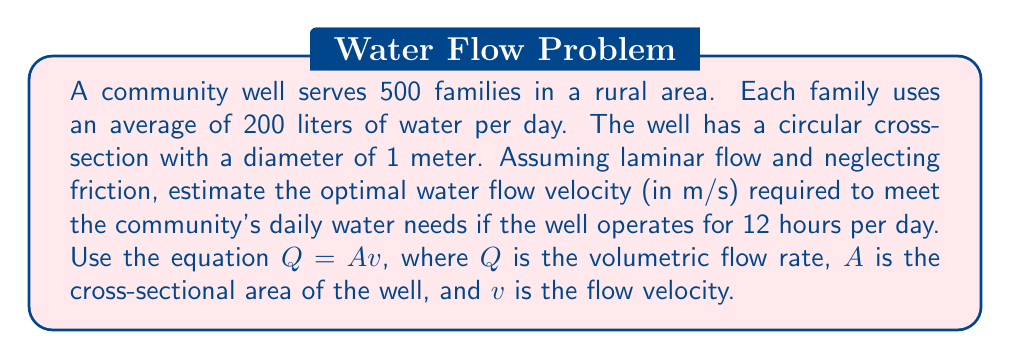Could you help me with this problem? To solve this problem, we'll follow these steps:

1. Calculate the total daily water requirement for the community:
   $$Q_{total} = 500 \text{ families} \times 200 \text{ L/family/day} = 100,000 \text{ L/day}$$

2. Convert the total water requirement to cubic meters:
   $$Q_{total} = 100,000 \text{ L/day} \times \frac{1 \text{ m}^3}{1000 \text{ L}} = 100 \text{ m}^3/day$$

3. Calculate the required flow rate per hour, given that the well operates for 12 hours:
   $$Q_{hourly} = \frac{100 \text{ m}^3/day}{12 \text{ hours/day}} = \frac{25}{3} \text{ m}^3/hour$$

4. Convert the hourly flow rate to cubic meters per second:
   $$Q = \frac{25}{3} \text{ m}^3/hour} \times \frac{1 \text{ hour}}{3600 \text{ seconds}} = \frac{25}{10800} \text{ m}^3/s$$

5. Calculate the cross-sectional area of the well:
   $$A = \pi r^2 = \pi \times (0.5 \text{ m})^2 = \frac{\pi}{4} \text{ m}^2$$

6. Use the equation $Q = Av$ to solve for the velocity:
   $$v = \frac{Q}{A} = \frac{25}{10800} \div \frac{\pi}{4} = \frac{100}{10800\pi} \approx 0.00295 \text{ m/s}$$

7. Round the result to 3 decimal places for a reasonable precision:
   $$v \approx 0.003 \text{ m/s}$$
Answer: 0.003 m/s 